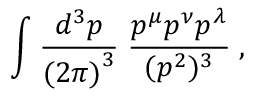Convert formula to latex. <formula><loc_0><loc_0><loc_500><loc_500>\int \frac { d ^ { 3 } p } { { ( 2 \pi ) } ^ { 3 } } \, \frac { p ^ { \mu } p ^ { \nu } p ^ { \lambda } } { ( p ^ { 2 } ) ^ { 3 } } \, ,</formula> 